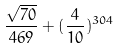<formula> <loc_0><loc_0><loc_500><loc_500>\frac { \sqrt { 7 0 } } { 4 6 9 } + ( \frac { 4 } { 1 0 } ) ^ { 3 0 4 }</formula> 